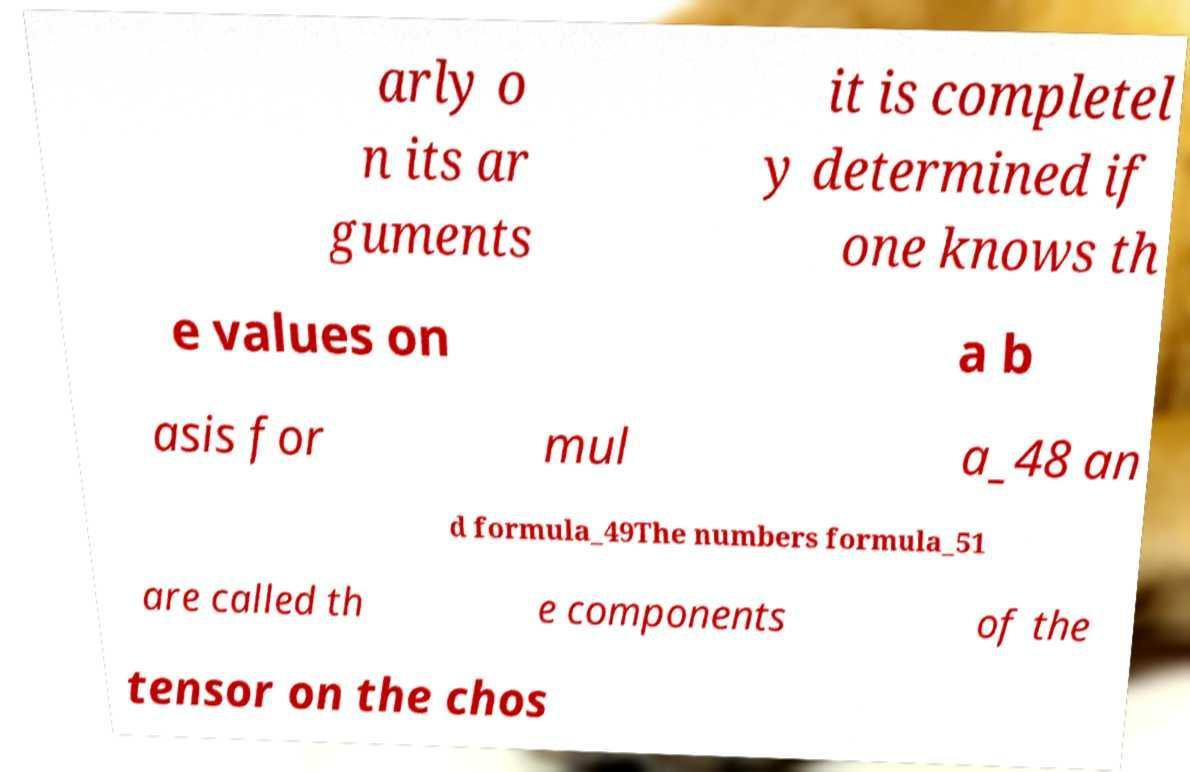Can you read and provide the text displayed in the image?This photo seems to have some interesting text. Can you extract and type it out for me? arly o n its ar guments it is completel y determined if one knows th e values on a b asis for mul a_48 an d formula_49The numbers formula_51 are called th e components of the tensor on the chos 